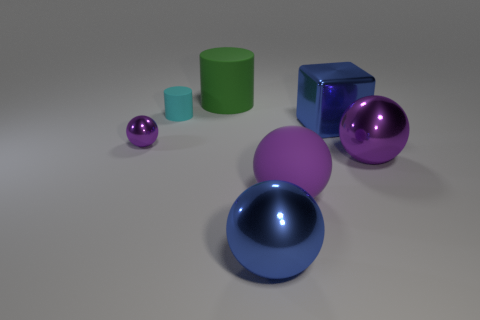Subtract all purple spheres. How many were subtracted if there are1purple spheres left? 2 Subtract all large purple metallic balls. How many balls are left? 3 Add 3 tiny spheres. How many objects exist? 10 Subtract 4 spheres. How many spheres are left? 0 Subtract all purple spheres. How many spheres are left? 1 Subtract all cylinders. How many objects are left? 5 Subtract all red cubes. Subtract all cyan cylinders. How many cubes are left? 1 Subtract all purple cylinders. How many purple balls are left? 3 Subtract all green metal spheres. Subtract all small purple spheres. How many objects are left? 6 Add 2 metallic spheres. How many metallic spheres are left? 5 